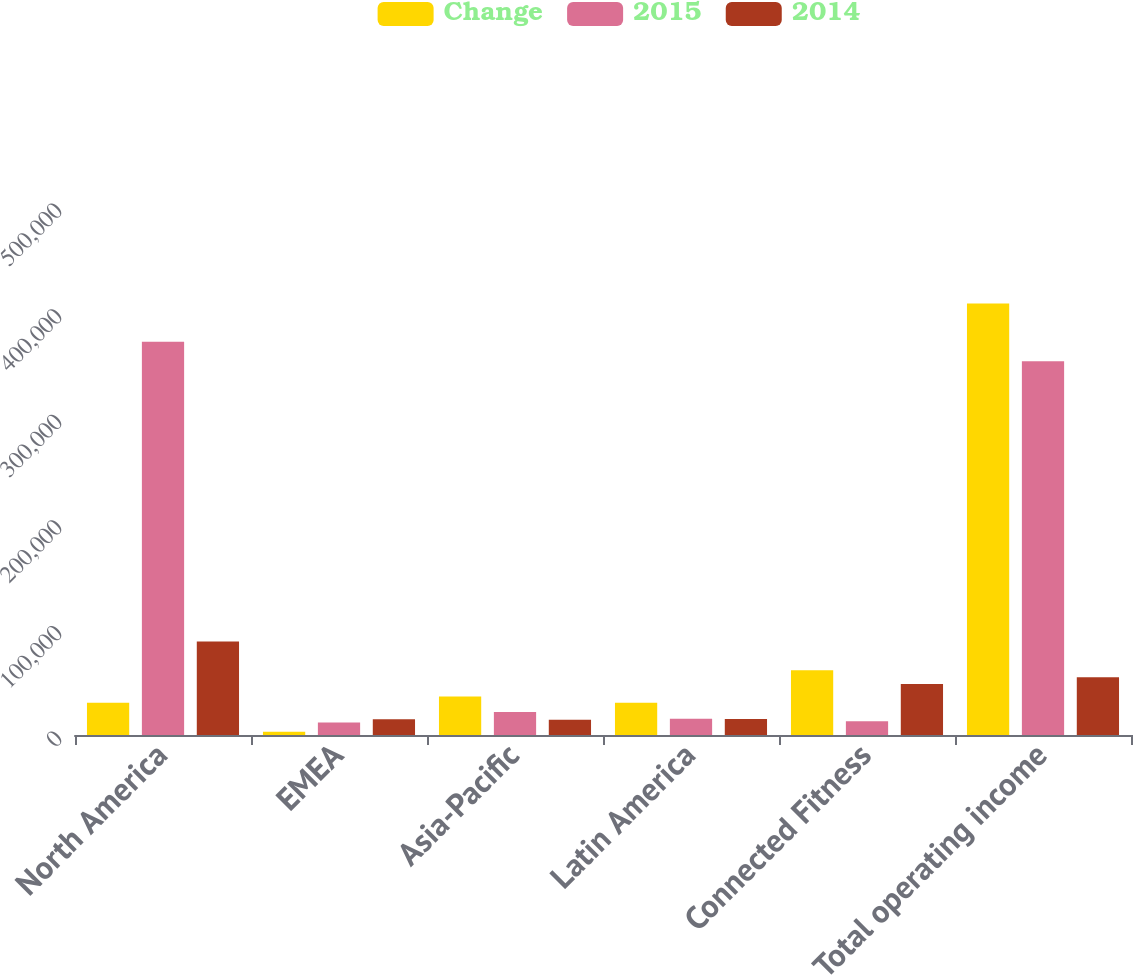Convert chart. <chart><loc_0><loc_0><loc_500><loc_500><stacked_bar_chart><ecel><fcel>North America<fcel>EMEA<fcel>Asia-Pacific<fcel>Latin America<fcel>Connected Fitness<fcel>Total operating income<nl><fcel>Change<fcel>30593<fcel>3122<fcel>36358<fcel>30593<fcel>61301<fcel>408547<nl><fcel>2015<fcel>372347<fcel>11763<fcel>21858<fcel>15423<fcel>13064<fcel>353955<nl><fcel>2014<fcel>88614<fcel>14885<fcel>14500<fcel>15170<fcel>48237<fcel>54592<nl></chart> 